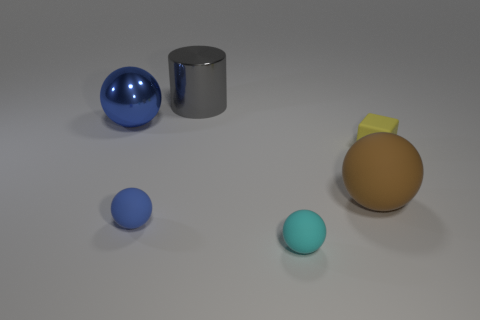Are there any other spheres of the same color as the big metallic sphere?
Your answer should be very brief. Yes. What number of big things are gray shiny things or blue metallic objects?
Provide a short and direct response. 2. Does the large thing that is in front of the blue shiny object have the same material as the small yellow cube?
Your answer should be compact. Yes. What shape is the blue thing that is behind the matte ball to the left of the small thing in front of the small blue matte object?
Your response must be concise. Sphere. What number of cyan things are large metallic cylinders or tiny rubber blocks?
Keep it short and to the point. 0. Is the number of yellow rubber blocks that are in front of the blue metal thing the same as the number of rubber objects that are behind the brown object?
Give a very brief answer. Yes. Do the small rubber thing right of the cyan matte ball and the small matte object that is to the left of the cyan ball have the same shape?
Your answer should be compact. No. Are there any other things that are the same shape as the tiny yellow matte object?
Provide a short and direct response. No. The yellow object that is made of the same material as the cyan object is what shape?
Make the answer very short. Cube. Are there the same number of gray things in front of the tiny yellow block and brown balls?
Keep it short and to the point. No. 